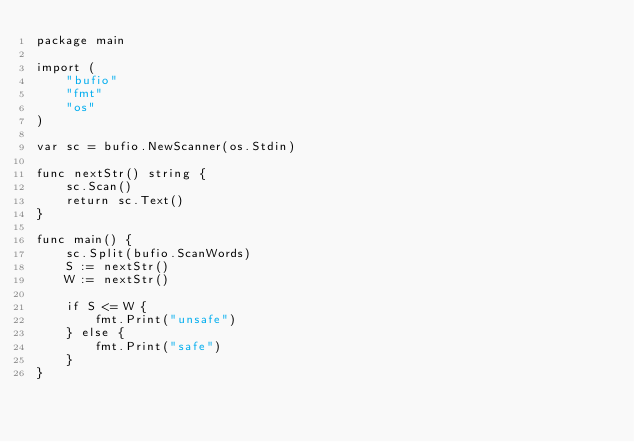<code> <loc_0><loc_0><loc_500><loc_500><_Go_>package main

import (
	"bufio"
	"fmt"
	"os"
)

var sc = bufio.NewScanner(os.Stdin)

func nextStr() string {
	sc.Scan()
	return sc.Text()
}

func main() {
	sc.Split(bufio.ScanWords)
	S := nextStr()
	W := nextStr()

	if S <= W {
		fmt.Print("unsafe")
	} else {
		fmt.Print("safe")
	}
}
</code> 